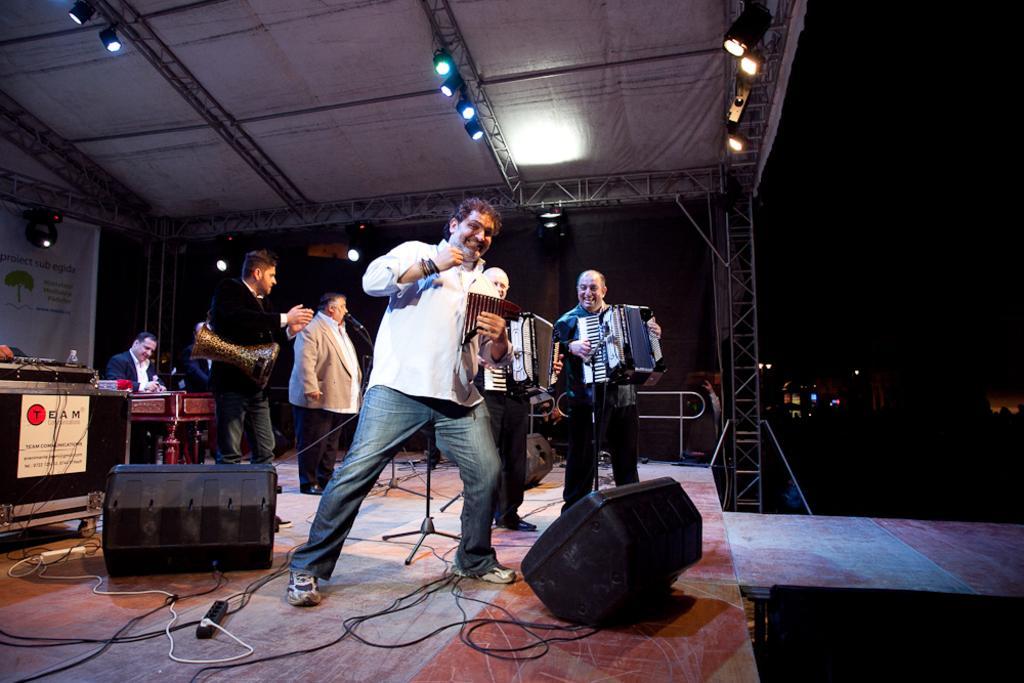Can you describe this image briefly? In this image there are few people performing on a stage with musical instruments, on the top there is shed, lighting. 